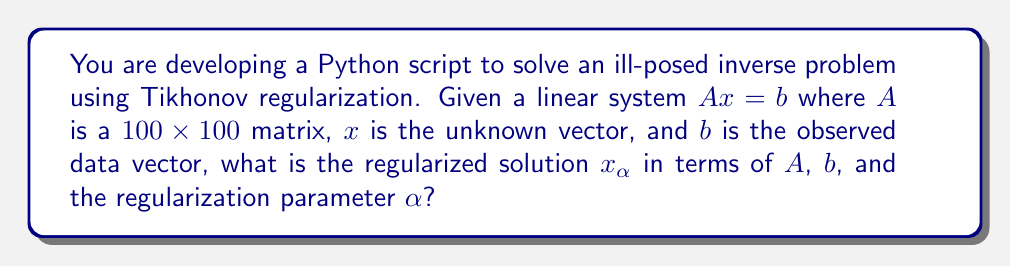Help me with this question. To solve this inverse problem using Tikhonov regularization, we follow these steps:

1. The standard form of Tikhonov regularization minimizes:

   $$\min_x \|Ax - b\|^2 + \alpha\|x\|^2$$

   where $\alpha > 0$ is the regularization parameter.

2. The solution to this minimization problem is given by:

   $$x_\alpha = (A^TA + \alpha I)^{-1}A^Tb$$

   where $I$ is the $100 \times 100$ identity matrix.

3. In Python, you would typically implement this solution using NumPy:

   ```python
   import numpy as np

   def tikhonov_regularization(A, b, alpha):
       n = A.shape[1]
       return np.linalg.inv(A.T @ A + alpha * np.eye(n)) @ A.T @ b
   ```

4. The regularization parameter $\alpha$ controls the trade-off between fitting the data and the smoothness of the solution. A larger $\alpha$ results in a smoother solution but may fit the data less well, while a smaller $\alpha$ fits the data better but may lead to an unstable solution.

5. The choice of $\alpha$ is crucial and often determined using methods like the L-curve or generalized cross-validation.

The regularized solution $x_\alpha$ provides a stable approximation to the ill-posed inverse problem, reducing the impact of noise and ill-conditioning in the original system.
Answer: $x_\alpha = (A^TA + \alpha I)^{-1}A^Tb$ 